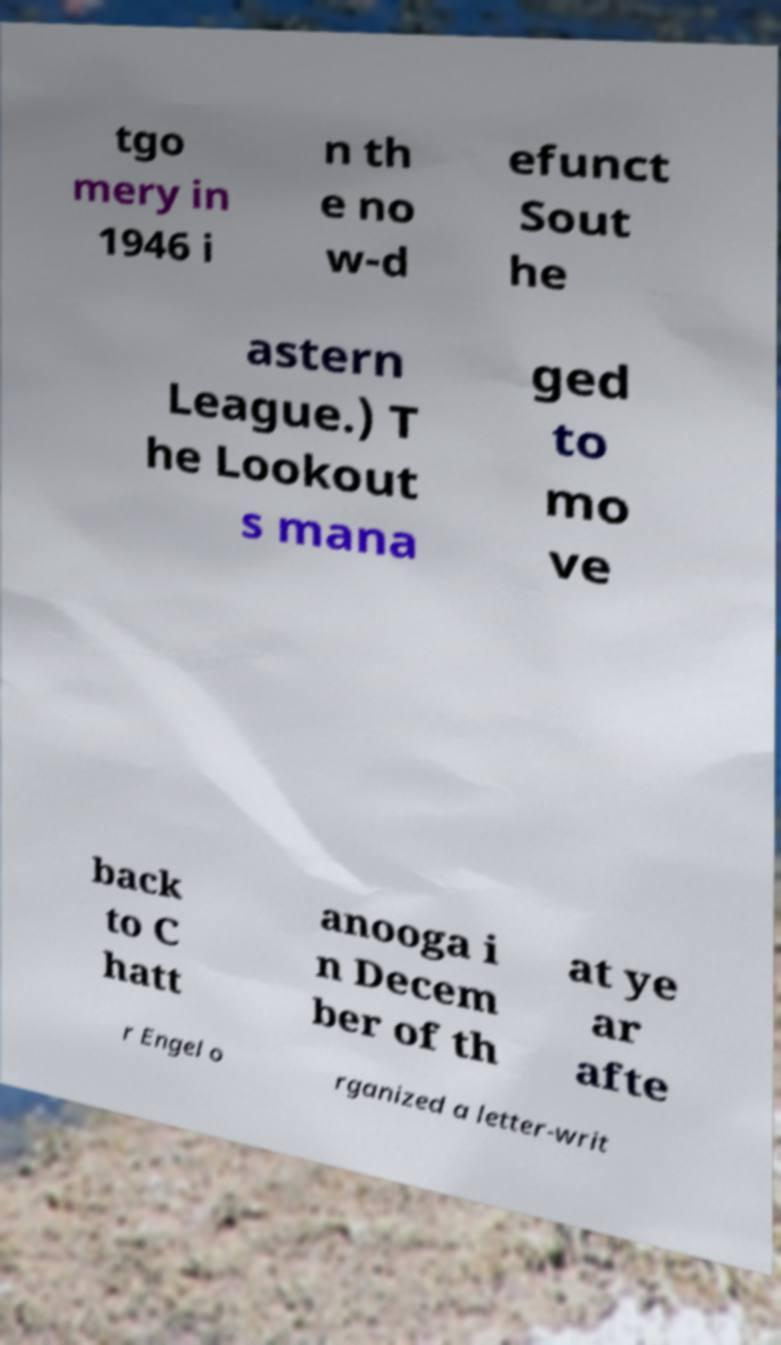I need the written content from this picture converted into text. Can you do that? tgo mery in 1946 i n th e no w-d efunct Sout he astern League.) T he Lookout s mana ged to mo ve back to C hatt anooga i n Decem ber of th at ye ar afte r Engel o rganized a letter-writ 